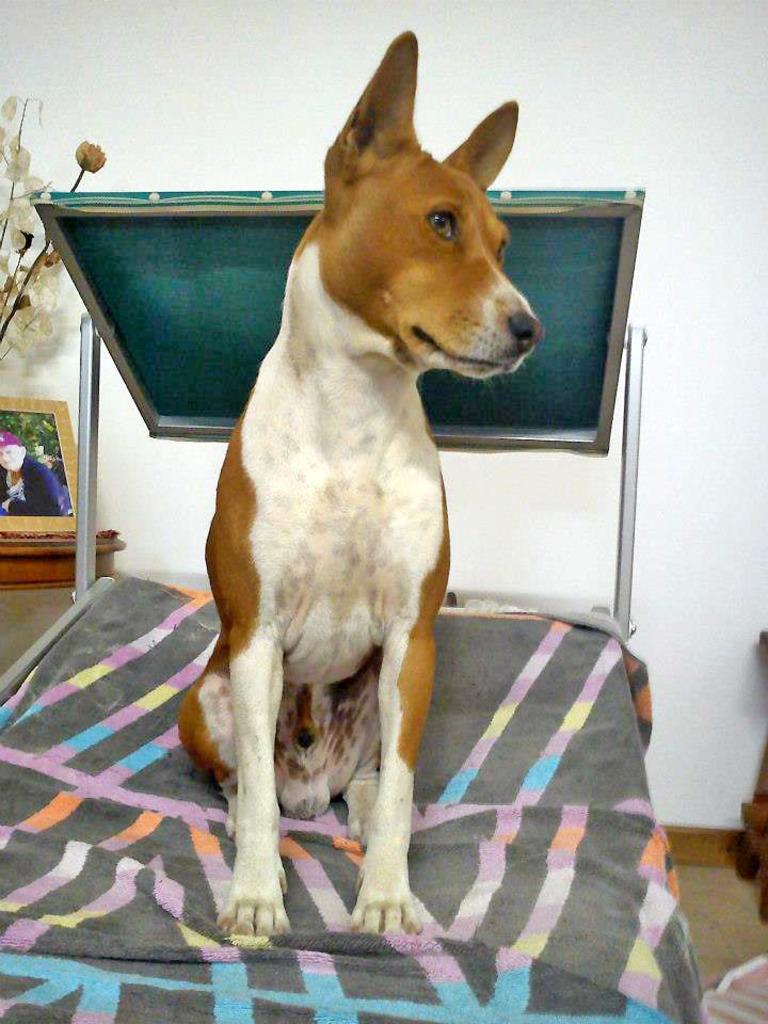Could you give a brief overview of what you see in this image? In this picture, we can see a dog is sitting on an object and behind the dog there is a photo frame, house plant and a white wall. 